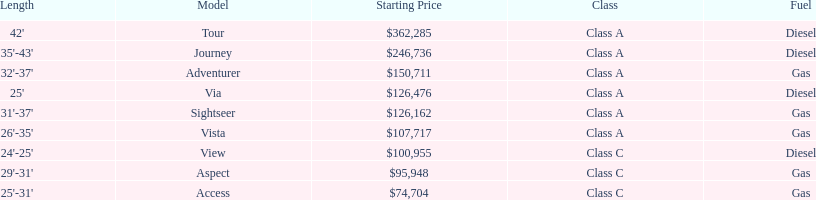How many models are available in lengths longer than 30 feet? 7. 